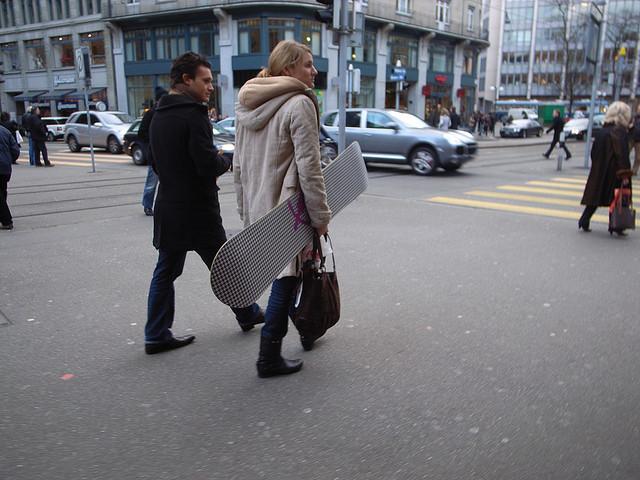What is the woman carrying above her purse?
Give a very brief answer. Snowboard. Are they walking on a beach?
Short answer required. No. What color is the man's coat?
Keep it brief. Black. 